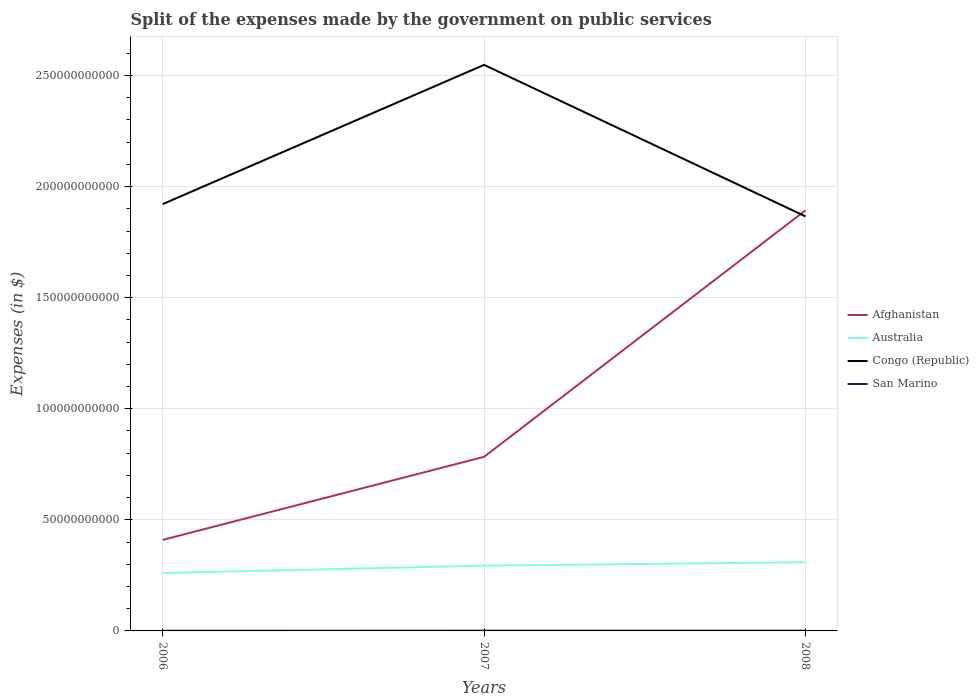How many different coloured lines are there?
Your answer should be compact. 4. Does the line corresponding to Afghanistan intersect with the line corresponding to Congo (Republic)?
Your response must be concise. Yes. Across all years, what is the maximum expenses made by the government on public services in Australia?
Your answer should be compact. 2.60e+1. In which year was the expenses made by the government on public services in Congo (Republic) maximum?
Keep it short and to the point. 2008. What is the total expenses made by the government on public services in San Marino in the graph?
Provide a short and direct response. -3.64e+07. What is the difference between the highest and the second highest expenses made by the government on public services in Afghanistan?
Offer a very short reply. 1.48e+11. Is the expenses made by the government on public services in San Marino strictly greater than the expenses made by the government on public services in Australia over the years?
Give a very brief answer. Yes. How many years are there in the graph?
Your response must be concise. 3. What is the difference between two consecutive major ticks on the Y-axis?
Your answer should be very brief. 5.00e+1. What is the title of the graph?
Ensure brevity in your answer.  Split of the expenses made by the government on public services. Does "Brazil" appear as one of the legend labels in the graph?
Keep it short and to the point. No. What is the label or title of the X-axis?
Give a very brief answer. Years. What is the label or title of the Y-axis?
Keep it short and to the point. Expenses (in $). What is the Expenses (in $) of Afghanistan in 2006?
Provide a short and direct response. 4.10e+1. What is the Expenses (in $) of Australia in 2006?
Ensure brevity in your answer.  2.60e+1. What is the Expenses (in $) of Congo (Republic) in 2006?
Your response must be concise. 1.92e+11. What is the Expenses (in $) of San Marino in 2006?
Provide a short and direct response. 9.27e+07. What is the Expenses (in $) of Afghanistan in 2007?
Your answer should be compact. 7.84e+1. What is the Expenses (in $) of Australia in 2007?
Provide a short and direct response. 2.94e+1. What is the Expenses (in $) of Congo (Republic) in 2007?
Make the answer very short. 2.55e+11. What is the Expenses (in $) in San Marino in 2007?
Your response must be concise. 1.09e+08. What is the Expenses (in $) in Afghanistan in 2008?
Offer a very short reply. 1.89e+11. What is the Expenses (in $) of Australia in 2008?
Make the answer very short. 3.09e+1. What is the Expenses (in $) in Congo (Republic) in 2008?
Make the answer very short. 1.87e+11. What is the Expenses (in $) of San Marino in 2008?
Provide a succinct answer. 1.29e+08. Across all years, what is the maximum Expenses (in $) in Afghanistan?
Make the answer very short. 1.89e+11. Across all years, what is the maximum Expenses (in $) of Australia?
Offer a very short reply. 3.09e+1. Across all years, what is the maximum Expenses (in $) of Congo (Republic)?
Provide a short and direct response. 2.55e+11. Across all years, what is the maximum Expenses (in $) in San Marino?
Give a very brief answer. 1.29e+08. Across all years, what is the minimum Expenses (in $) in Afghanistan?
Provide a short and direct response. 4.10e+1. Across all years, what is the minimum Expenses (in $) of Australia?
Your answer should be very brief. 2.60e+1. Across all years, what is the minimum Expenses (in $) of Congo (Republic)?
Give a very brief answer. 1.87e+11. Across all years, what is the minimum Expenses (in $) in San Marino?
Keep it short and to the point. 9.27e+07. What is the total Expenses (in $) in Afghanistan in the graph?
Your answer should be compact. 3.09e+11. What is the total Expenses (in $) of Australia in the graph?
Provide a short and direct response. 8.63e+1. What is the total Expenses (in $) of Congo (Republic) in the graph?
Ensure brevity in your answer.  6.33e+11. What is the total Expenses (in $) in San Marino in the graph?
Your answer should be very brief. 3.31e+08. What is the difference between the Expenses (in $) of Afghanistan in 2006 and that in 2007?
Offer a terse response. -3.74e+1. What is the difference between the Expenses (in $) in Australia in 2006 and that in 2007?
Your answer should be compact. -3.32e+09. What is the difference between the Expenses (in $) in Congo (Republic) in 2006 and that in 2007?
Make the answer very short. -6.27e+1. What is the difference between the Expenses (in $) in San Marino in 2006 and that in 2007?
Provide a succinct answer. -1.60e+07. What is the difference between the Expenses (in $) in Afghanistan in 2006 and that in 2008?
Give a very brief answer. -1.48e+11. What is the difference between the Expenses (in $) of Australia in 2006 and that in 2008?
Your response must be concise. -4.88e+09. What is the difference between the Expenses (in $) in Congo (Republic) in 2006 and that in 2008?
Ensure brevity in your answer.  5.52e+09. What is the difference between the Expenses (in $) of San Marino in 2006 and that in 2008?
Ensure brevity in your answer.  -3.64e+07. What is the difference between the Expenses (in $) in Afghanistan in 2007 and that in 2008?
Your answer should be compact. -1.11e+11. What is the difference between the Expenses (in $) in Australia in 2007 and that in 2008?
Your response must be concise. -1.55e+09. What is the difference between the Expenses (in $) of Congo (Republic) in 2007 and that in 2008?
Keep it short and to the point. 6.82e+1. What is the difference between the Expenses (in $) of San Marino in 2007 and that in 2008?
Offer a terse response. -2.04e+07. What is the difference between the Expenses (in $) in Afghanistan in 2006 and the Expenses (in $) in Australia in 2007?
Offer a very short reply. 1.16e+1. What is the difference between the Expenses (in $) of Afghanistan in 2006 and the Expenses (in $) of Congo (Republic) in 2007?
Make the answer very short. -2.14e+11. What is the difference between the Expenses (in $) in Afghanistan in 2006 and the Expenses (in $) in San Marino in 2007?
Offer a very short reply. 4.09e+1. What is the difference between the Expenses (in $) in Australia in 2006 and the Expenses (in $) in Congo (Republic) in 2007?
Make the answer very short. -2.29e+11. What is the difference between the Expenses (in $) of Australia in 2006 and the Expenses (in $) of San Marino in 2007?
Your response must be concise. 2.59e+1. What is the difference between the Expenses (in $) in Congo (Republic) in 2006 and the Expenses (in $) in San Marino in 2007?
Offer a terse response. 1.92e+11. What is the difference between the Expenses (in $) of Afghanistan in 2006 and the Expenses (in $) of Australia in 2008?
Give a very brief answer. 1.01e+1. What is the difference between the Expenses (in $) of Afghanistan in 2006 and the Expenses (in $) of Congo (Republic) in 2008?
Offer a terse response. -1.46e+11. What is the difference between the Expenses (in $) of Afghanistan in 2006 and the Expenses (in $) of San Marino in 2008?
Provide a short and direct response. 4.09e+1. What is the difference between the Expenses (in $) of Australia in 2006 and the Expenses (in $) of Congo (Republic) in 2008?
Make the answer very short. -1.61e+11. What is the difference between the Expenses (in $) in Australia in 2006 and the Expenses (in $) in San Marino in 2008?
Ensure brevity in your answer.  2.59e+1. What is the difference between the Expenses (in $) in Congo (Republic) in 2006 and the Expenses (in $) in San Marino in 2008?
Offer a terse response. 1.92e+11. What is the difference between the Expenses (in $) of Afghanistan in 2007 and the Expenses (in $) of Australia in 2008?
Your answer should be very brief. 4.74e+1. What is the difference between the Expenses (in $) of Afghanistan in 2007 and the Expenses (in $) of Congo (Republic) in 2008?
Make the answer very short. -1.08e+11. What is the difference between the Expenses (in $) in Afghanistan in 2007 and the Expenses (in $) in San Marino in 2008?
Your answer should be very brief. 7.82e+1. What is the difference between the Expenses (in $) of Australia in 2007 and the Expenses (in $) of Congo (Republic) in 2008?
Ensure brevity in your answer.  -1.57e+11. What is the difference between the Expenses (in $) in Australia in 2007 and the Expenses (in $) in San Marino in 2008?
Keep it short and to the point. 2.92e+1. What is the difference between the Expenses (in $) in Congo (Republic) in 2007 and the Expenses (in $) in San Marino in 2008?
Keep it short and to the point. 2.55e+11. What is the average Expenses (in $) of Afghanistan per year?
Provide a succinct answer. 1.03e+11. What is the average Expenses (in $) of Australia per year?
Ensure brevity in your answer.  2.88e+1. What is the average Expenses (in $) in Congo (Republic) per year?
Your response must be concise. 2.11e+11. What is the average Expenses (in $) of San Marino per year?
Provide a short and direct response. 1.10e+08. In the year 2006, what is the difference between the Expenses (in $) in Afghanistan and Expenses (in $) in Australia?
Offer a terse response. 1.49e+1. In the year 2006, what is the difference between the Expenses (in $) in Afghanistan and Expenses (in $) in Congo (Republic)?
Provide a succinct answer. -1.51e+11. In the year 2006, what is the difference between the Expenses (in $) of Afghanistan and Expenses (in $) of San Marino?
Your response must be concise. 4.09e+1. In the year 2006, what is the difference between the Expenses (in $) of Australia and Expenses (in $) of Congo (Republic)?
Offer a terse response. -1.66e+11. In the year 2006, what is the difference between the Expenses (in $) of Australia and Expenses (in $) of San Marino?
Offer a terse response. 2.60e+1. In the year 2006, what is the difference between the Expenses (in $) in Congo (Republic) and Expenses (in $) in San Marino?
Your answer should be compact. 1.92e+11. In the year 2007, what is the difference between the Expenses (in $) of Afghanistan and Expenses (in $) of Australia?
Your answer should be compact. 4.90e+1. In the year 2007, what is the difference between the Expenses (in $) in Afghanistan and Expenses (in $) in Congo (Republic)?
Give a very brief answer. -1.76e+11. In the year 2007, what is the difference between the Expenses (in $) in Afghanistan and Expenses (in $) in San Marino?
Give a very brief answer. 7.83e+1. In the year 2007, what is the difference between the Expenses (in $) in Australia and Expenses (in $) in Congo (Republic)?
Give a very brief answer. -2.25e+11. In the year 2007, what is the difference between the Expenses (in $) in Australia and Expenses (in $) in San Marino?
Offer a very short reply. 2.93e+1. In the year 2007, what is the difference between the Expenses (in $) in Congo (Republic) and Expenses (in $) in San Marino?
Ensure brevity in your answer.  2.55e+11. In the year 2008, what is the difference between the Expenses (in $) in Afghanistan and Expenses (in $) in Australia?
Make the answer very short. 1.58e+11. In the year 2008, what is the difference between the Expenses (in $) in Afghanistan and Expenses (in $) in Congo (Republic)?
Give a very brief answer. 2.70e+09. In the year 2008, what is the difference between the Expenses (in $) of Afghanistan and Expenses (in $) of San Marino?
Offer a terse response. 1.89e+11. In the year 2008, what is the difference between the Expenses (in $) in Australia and Expenses (in $) in Congo (Republic)?
Make the answer very short. -1.56e+11. In the year 2008, what is the difference between the Expenses (in $) of Australia and Expenses (in $) of San Marino?
Your answer should be compact. 3.08e+1. In the year 2008, what is the difference between the Expenses (in $) of Congo (Republic) and Expenses (in $) of San Marino?
Your response must be concise. 1.86e+11. What is the ratio of the Expenses (in $) of Afghanistan in 2006 to that in 2007?
Your answer should be compact. 0.52. What is the ratio of the Expenses (in $) in Australia in 2006 to that in 2007?
Provide a succinct answer. 0.89. What is the ratio of the Expenses (in $) of Congo (Republic) in 2006 to that in 2007?
Your answer should be compact. 0.75. What is the ratio of the Expenses (in $) in San Marino in 2006 to that in 2007?
Make the answer very short. 0.85. What is the ratio of the Expenses (in $) of Afghanistan in 2006 to that in 2008?
Your response must be concise. 0.22. What is the ratio of the Expenses (in $) of Australia in 2006 to that in 2008?
Make the answer very short. 0.84. What is the ratio of the Expenses (in $) of Congo (Republic) in 2006 to that in 2008?
Your answer should be very brief. 1.03. What is the ratio of the Expenses (in $) of San Marino in 2006 to that in 2008?
Your response must be concise. 0.72. What is the ratio of the Expenses (in $) of Afghanistan in 2007 to that in 2008?
Provide a short and direct response. 0.41. What is the ratio of the Expenses (in $) in Australia in 2007 to that in 2008?
Your answer should be very brief. 0.95. What is the ratio of the Expenses (in $) of Congo (Republic) in 2007 to that in 2008?
Ensure brevity in your answer.  1.37. What is the ratio of the Expenses (in $) in San Marino in 2007 to that in 2008?
Make the answer very short. 0.84. What is the difference between the highest and the second highest Expenses (in $) of Afghanistan?
Provide a short and direct response. 1.11e+11. What is the difference between the highest and the second highest Expenses (in $) of Australia?
Provide a short and direct response. 1.55e+09. What is the difference between the highest and the second highest Expenses (in $) in Congo (Republic)?
Your answer should be very brief. 6.27e+1. What is the difference between the highest and the second highest Expenses (in $) of San Marino?
Your answer should be very brief. 2.04e+07. What is the difference between the highest and the lowest Expenses (in $) in Afghanistan?
Your answer should be compact. 1.48e+11. What is the difference between the highest and the lowest Expenses (in $) of Australia?
Provide a short and direct response. 4.88e+09. What is the difference between the highest and the lowest Expenses (in $) in Congo (Republic)?
Offer a very short reply. 6.82e+1. What is the difference between the highest and the lowest Expenses (in $) of San Marino?
Make the answer very short. 3.64e+07. 